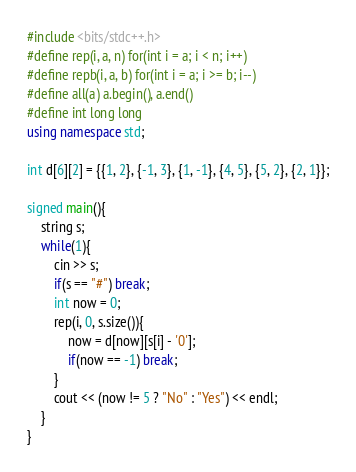<code> <loc_0><loc_0><loc_500><loc_500><_C++_>#include <bits/stdc++.h>
#define rep(i, a, n) for(int i = a; i < n; i++)
#define repb(i, a, b) for(int i = a; i >= b; i--)
#define all(a) a.begin(), a.end()
#define int long long
using namespace std;

int d[6][2] = {{1, 2}, {-1, 3}, {1, -1}, {4, 5}, {5, 2}, {2, 1}};

signed main(){
    string s;
    while(1){
        cin >> s;
        if(s == "#") break;
        int now = 0;
        rep(i, 0, s.size()){
            now = d[now][s[i] - '0'];
            if(now == -1) break;
        }
        cout << (now != 5 ? "No" : "Yes") << endl;
    }
}</code> 